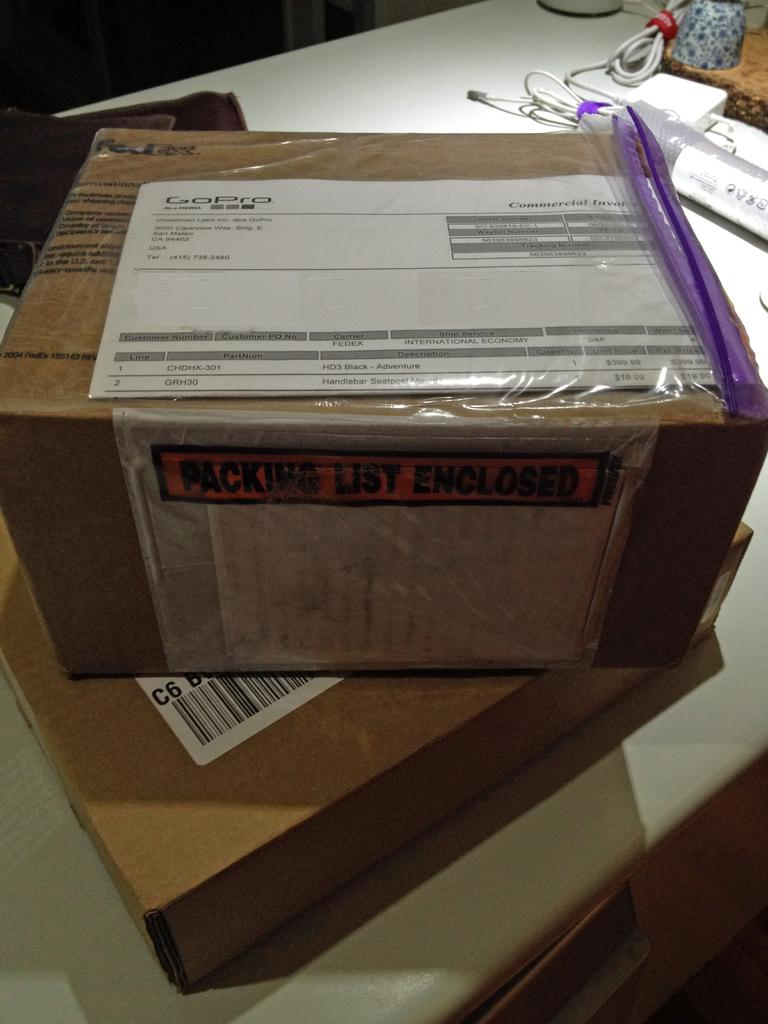How many boxes are present in the image? There are two boxes in the image. What else can be seen in the image besides the boxes? Wires are visible in the image, as well as a device and objects on the table. Can you describe the device in the image? Unfortunately, the facts provided do not give enough information to describe the device in detail. What is the nature of the objects on the table in the image? The facts provided do not specify the nature of the objects on the table. How many kittens are present in the image? There are no kittens present in the image. What type of division is being performed on the table in the image? There is no division being performed in the image; the facts provided do not mention any mathematical operations. 